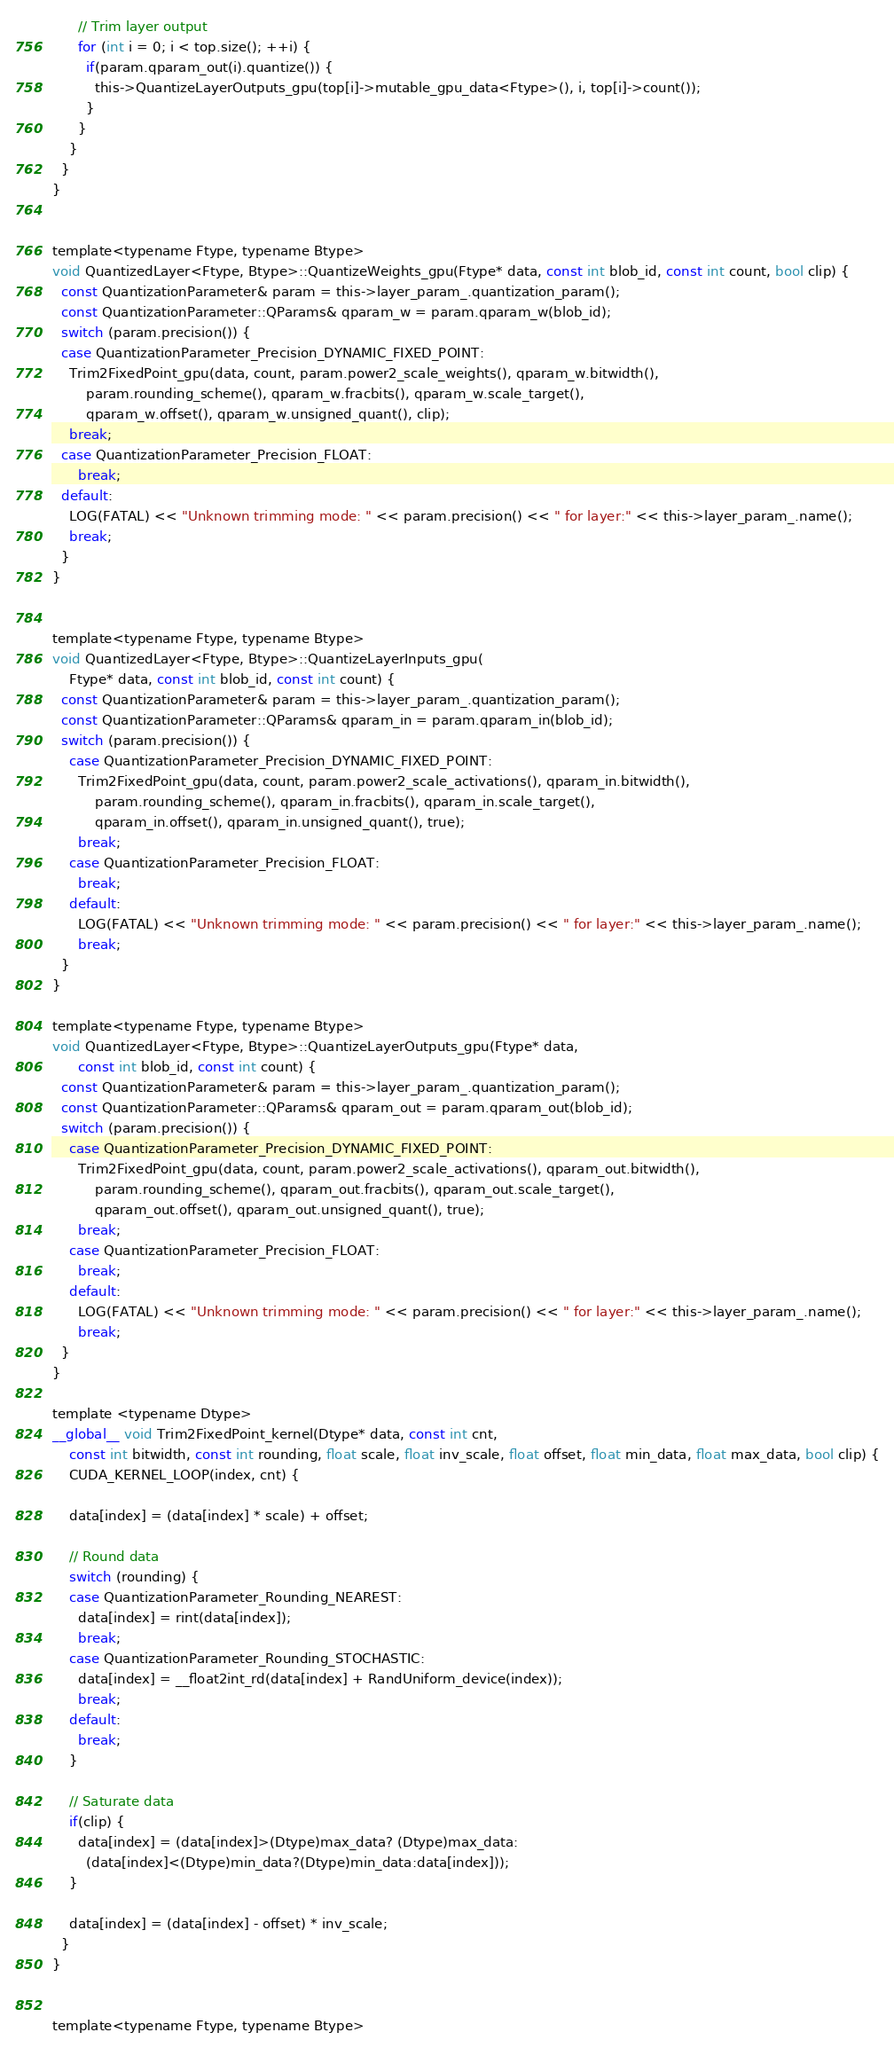Convert code to text. <code><loc_0><loc_0><loc_500><loc_500><_Cuda_>      // Trim layer output
      for (int i = 0; i < top.size(); ++i) {
        if(param.qparam_out(i).quantize()) {
          this->QuantizeLayerOutputs_gpu(top[i]->mutable_gpu_data<Ftype>(), i, top[i]->count());
        }
      }
    }
  }
}


template<typename Ftype, typename Btype>
void QuantizedLayer<Ftype, Btype>::QuantizeWeights_gpu(Ftype* data, const int blob_id, const int count, bool clip) {
  const QuantizationParameter& param = this->layer_param_.quantization_param();
  const QuantizationParameter::QParams& qparam_w = param.qparam_w(blob_id);
  switch (param.precision()) {
  case QuantizationParameter_Precision_DYNAMIC_FIXED_POINT:
    Trim2FixedPoint_gpu(data, count, param.power2_scale_weights(), qparam_w.bitwidth(),
        param.rounding_scheme(), qparam_w.fracbits(), qparam_w.scale_target(),
        qparam_w.offset(), qparam_w.unsigned_quant(), clip);
    break;
  case QuantizationParameter_Precision_FLOAT:
	  break;
  default:
    LOG(FATAL) << "Unknown trimming mode: " << param.precision() << " for layer:" << this->layer_param_.name();
    break;
  }
}


template<typename Ftype, typename Btype>
void QuantizedLayer<Ftype, Btype>::QuantizeLayerInputs_gpu(
    Ftype* data, const int blob_id, const int count) {
  const QuantizationParameter& param = this->layer_param_.quantization_param();
  const QuantizationParameter::QParams& qparam_in = param.qparam_in(blob_id);
  switch (param.precision()) {
    case QuantizationParameter_Precision_DYNAMIC_FIXED_POINT:
      Trim2FixedPoint_gpu(data, count, param.power2_scale_activations(), qparam_in.bitwidth(),
          param.rounding_scheme(), qparam_in.fracbits(), qparam_in.scale_target(),
          qparam_in.offset(), qparam_in.unsigned_quant(), true);
      break;
    case QuantizationParameter_Precision_FLOAT:
  	  break;
    default:
      LOG(FATAL) << "Unknown trimming mode: " << param.precision() << " for layer:" << this->layer_param_.name();
      break;
  }
}

template<typename Ftype, typename Btype>
void QuantizedLayer<Ftype, Btype>::QuantizeLayerOutputs_gpu(Ftype* data,
      const int blob_id, const int count) {
  const QuantizationParameter& param = this->layer_param_.quantization_param();
  const QuantizationParameter::QParams& qparam_out = param.qparam_out(blob_id);
  switch (param.precision()) {
    case QuantizationParameter_Precision_DYNAMIC_FIXED_POINT:
      Trim2FixedPoint_gpu(data, count, param.power2_scale_activations(), qparam_out.bitwidth(),
          param.rounding_scheme(), qparam_out.fracbits(), qparam_out.scale_target(),
          qparam_out.offset(), qparam_out.unsigned_quant(), true);
      break;
    case QuantizationParameter_Precision_FLOAT:
  	  break;
    default:
      LOG(FATAL) << "Unknown trimming mode: " << param.precision() << " for layer:" << this->layer_param_.name();
      break;
  }
}

template <typename Dtype>
__global__ void Trim2FixedPoint_kernel(Dtype* data, const int cnt,
    const int bitwidth, const int rounding, float scale, float inv_scale, float offset, float min_data, float max_data, bool clip) {
    CUDA_KERNEL_LOOP(index, cnt) {

    data[index] = (data[index] * scale) + offset;

    // Round data
    switch (rounding) {
    case QuantizationParameter_Rounding_NEAREST:
      data[index] = rint(data[index]);
      break;
    case QuantizationParameter_Rounding_STOCHASTIC:
      data[index] = __float2int_rd(data[index] + RandUniform_device(index));
      break;
    default:
      break;
    }

    // Saturate data
    if(clip) {
      data[index] = (data[index]>(Dtype)max_data? (Dtype)max_data:
        (data[index]<(Dtype)min_data?(Dtype)min_data:data[index]));
    }

    data[index] = (data[index] - offset) * inv_scale;
  }
}


template<typename Ftype, typename Btype></code> 